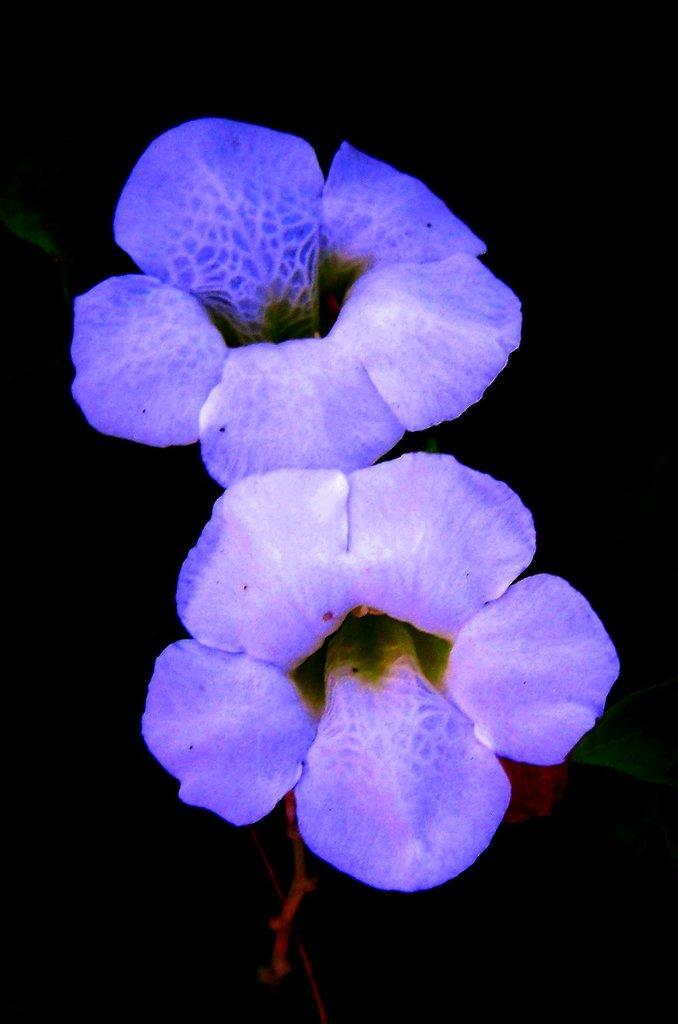Can you describe this image briefly? In the center of the image there flowers. The background of the image is black in color. 